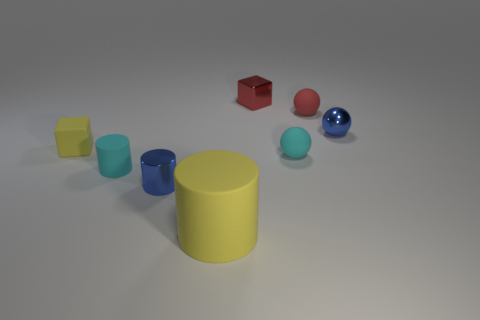There is a shiny object that is left of the large matte cylinder; is its color the same as the metallic sphere?
Offer a terse response. Yes. There is a small blue thing to the right of the tiny blue cylinder left of the red metal block; how many small red balls are in front of it?
Provide a succinct answer. 0. There is a tiny red metallic object; how many small metallic objects are right of it?
Give a very brief answer. 1. What is the color of the other object that is the same shape as the red metal thing?
Keep it short and to the point. Yellow. The tiny object that is on the right side of the yellow matte cylinder and in front of the small blue ball is made of what material?
Provide a short and direct response. Rubber. Is the size of the blue metal object behind the metal cylinder the same as the small red ball?
Keep it short and to the point. Yes. What material is the tiny red block?
Offer a terse response. Metal. There is a tiny cylinder in front of the small cyan cylinder; what is its color?
Provide a succinct answer. Blue. How many large objects are cyan matte balls or matte cylinders?
Keep it short and to the point. 1. There is a small metal cylinder to the right of the small yellow rubber object; is its color the same as the tiny metal sphere that is to the right of the big cylinder?
Make the answer very short. Yes. 